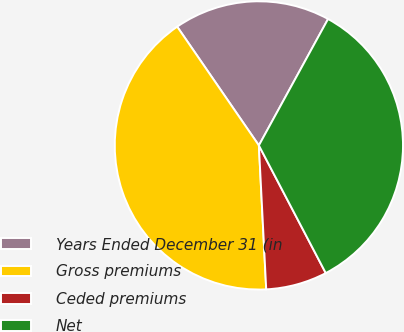<chart> <loc_0><loc_0><loc_500><loc_500><pie_chart><fcel>Years Ended December 31 (in<fcel>Gross premiums<fcel>Ceded premiums<fcel>Net<nl><fcel>17.56%<fcel>41.22%<fcel>6.87%<fcel>34.35%<nl></chart> 